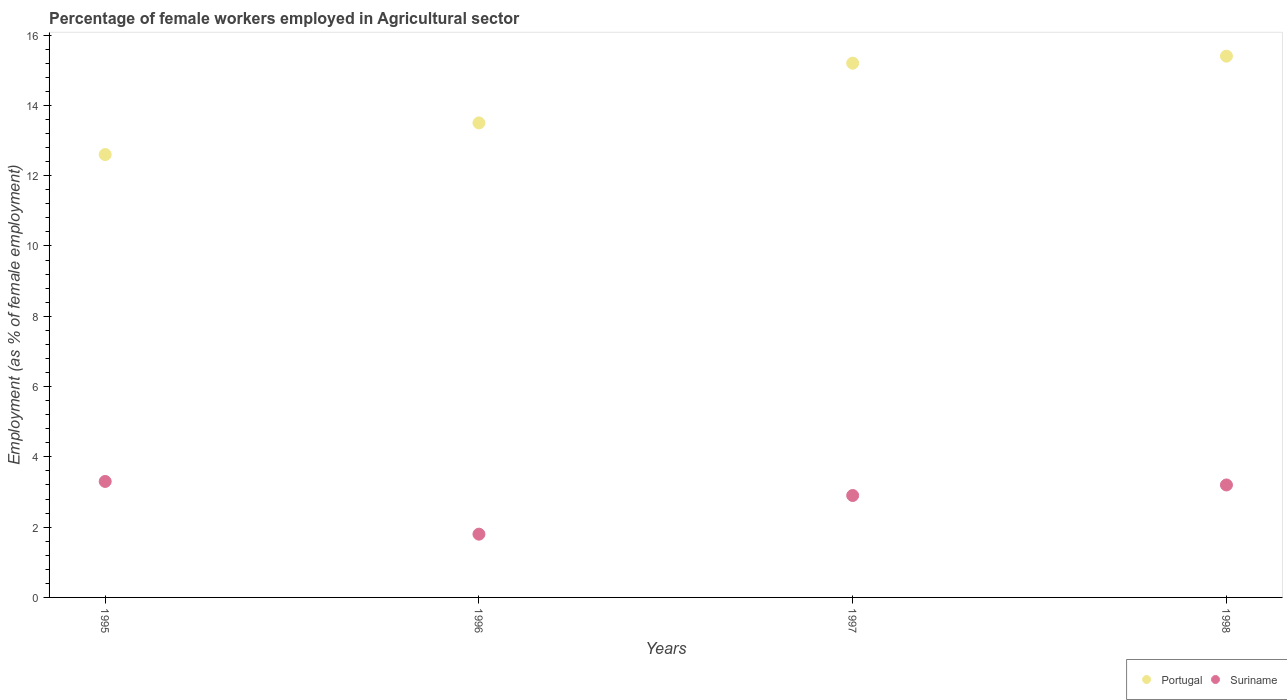Is the number of dotlines equal to the number of legend labels?
Offer a very short reply. Yes. What is the percentage of females employed in Agricultural sector in Suriname in 1996?
Ensure brevity in your answer.  1.8. Across all years, what is the maximum percentage of females employed in Agricultural sector in Portugal?
Offer a terse response. 15.4. Across all years, what is the minimum percentage of females employed in Agricultural sector in Portugal?
Ensure brevity in your answer.  12.6. In which year was the percentage of females employed in Agricultural sector in Portugal minimum?
Your response must be concise. 1995. What is the total percentage of females employed in Agricultural sector in Portugal in the graph?
Your response must be concise. 56.7. What is the difference between the percentage of females employed in Agricultural sector in Portugal in 1995 and that in 1998?
Make the answer very short. -2.8. What is the difference between the percentage of females employed in Agricultural sector in Suriname in 1997 and the percentage of females employed in Agricultural sector in Portugal in 1996?
Your answer should be compact. -10.6. What is the average percentage of females employed in Agricultural sector in Suriname per year?
Your answer should be compact. 2.8. In the year 1996, what is the difference between the percentage of females employed in Agricultural sector in Portugal and percentage of females employed in Agricultural sector in Suriname?
Offer a terse response. 11.7. In how many years, is the percentage of females employed in Agricultural sector in Portugal greater than 11.6 %?
Keep it short and to the point. 4. What is the ratio of the percentage of females employed in Agricultural sector in Portugal in 1995 to that in 1998?
Offer a very short reply. 0.82. Is the difference between the percentage of females employed in Agricultural sector in Portugal in 1995 and 1996 greater than the difference between the percentage of females employed in Agricultural sector in Suriname in 1995 and 1996?
Your answer should be compact. No. What is the difference between the highest and the second highest percentage of females employed in Agricultural sector in Portugal?
Offer a very short reply. 0.2. What is the difference between the highest and the lowest percentage of females employed in Agricultural sector in Suriname?
Ensure brevity in your answer.  1.5. In how many years, is the percentage of females employed in Agricultural sector in Suriname greater than the average percentage of females employed in Agricultural sector in Suriname taken over all years?
Your answer should be compact. 3. Is the sum of the percentage of females employed in Agricultural sector in Suriname in 1995 and 1996 greater than the maximum percentage of females employed in Agricultural sector in Portugal across all years?
Offer a very short reply. No. Is the percentage of females employed in Agricultural sector in Portugal strictly less than the percentage of females employed in Agricultural sector in Suriname over the years?
Ensure brevity in your answer.  No. How many dotlines are there?
Ensure brevity in your answer.  2. What is the difference between two consecutive major ticks on the Y-axis?
Offer a very short reply. 2. Does the graph contain any zero values?
Your answer should be very brief. No. Does the graph contain grids?
Your answer should be very brief. No. How many legend labels are there?
Provide a succinct answer. 2. How are the legend labels stacked?
Keep it short and to the point. Horizontal. What is the title of the graph?
Keep it short and to the point. Percentage of female workers employed in Agricultural sector. What is the label or title of the Y-axis?
Provide a succinct answer. Employment (as % of female employment). What is the Employment (as % of female employment) of Portugal in 1995?
Ensure brevity in your answer.  12.6. What is the Employment (as % of female employment) of Suriname in 1995?
Your answer should be compact. 3.3. What is the Employment (as % of female employment) of Suriname in 1996?
Make the answer very short. 1.8. What is the Employment (as % of female employment) in Portugal in 1997?
Give a very brief answer. 15.2. What is the Employment (as % of female employment) of Suriname in 1997?
Provide a succinct answer. 2.9. What is the Employment (as % of female employment) of Portugal in 1998?
Your answer should be very brief. 15.4. What is the Employment (as % of female employment) in Suriname in 1998?
Give a very brief answer. 3.2. Across all years, what is the maximum Employment (as % of female employment) in Portugal?
Your response must be concise. 15.4. Across all years, what is the maximum Employment (as % of female employment) in Suriname?
Keep it short and to the point. 3.3. Across all years, what is the minimum Employment (as % of female employment) in Portugal?
Give a very brief answer. 12.6. Across all years, what is the minimum Employment (as % of female employment) of Suriname?
Provide a short and direct response. 1.8. What is the total Employment (as % of female employment) in Portugal in the graph?
Your response must be concise. 56.7. What is the total Employment (as % of female employment) of Suriname in the graph?
Your answer should be compact. 11.2. What is the difference between the Employment (as % of female employment) of Suriname in 1995 and that in 1996?
Your answer should be very brief. 1.5. What is the difference between the Employment (as % of female employment) of Portugal in 1995 and that in 1998?
Keep it short and to the point. -2.8. What is the difference between the Employment (as % of female employment) of Suriname in 1995 and that in 1998?
Provide a succinct answer. 0.1. What is the difference between the Employment (as % of female employment) of Portugal in 1996 and that in 1998?
Keep it short and to the point. -1.9. What is the difference between the Employment (as % of female employment) of Suriname in 1996 and that in 1998?
Provide a short and direct response. -1.4. What is the difference between the Employment (as % of female employment) of Portugal in 1997 and that in 1998?
Make the answer very short. -0.2. What is the difference between the Employment (as % of female employment) of Portugal in 1995 and the Employment (as % of female employment) of Suriname in 1996?
Ensure brevity in your answer.  10.8. What is the difference between the Employment (as % of female employment) in Portugal in 1995 and the Employment (as % of female employment) in Suriname in 1997?
Keep it short and to the point. 9.7. What is the difference between the Employment (as % of female employment) of Portugal in 1996 and the Employment (as % of female employment) of Suriname in 1997?
Your answer should be very brief. 10.6. What is the difference between the Employment (as % of female employment) of Portugal in 1996 and the Employment (as % of female employment) of Suriname in 1998?
Offer a very short reply. 10.3. What is the average Employment (as % of female employment) in Portugal per year?
Provide a succinct answer. 14.18. In the year 1996, what is the difference between the Employment (as % of female employment) in Portugal and Employment (as % of female employment) in Suriname?
Offer a terse response. 11.7. In the year 1997, what is the difference between the Employment (as % of female employment) of Portugal and Employment (as % of female employment) of Suriname?
Give a very brief answer. 12.3. In the year 1998, what is the difference between the Employment (as % of female employment) of Portugal and Employment (as % of female employment) of Suriname?
Give a very brief answer. 12.2. What is the ratio of the Employment (as % of female employment) of Suriname in 1995 to that in 1996?
Keep it short and to the point. 1.83. What is the ratio of the Employment (as % of female employment) in Portugal in 1995 to that in 1997?
Offer a terse response. 0.83. What is the ratio of the Employment (as % of female employment) of Suriname in 1995 to that in 1997?
Keep it short and to the point. 1.14. What is the ratio of the Employment (as % of female employment) in Portugal in 1995 to that in 1998?
Keep it short and to the point. 0.82. What is the ratio of the Employment (as % of female employment) in Suriname in 1995 to that in 1998?
Keep it short and to the point. 1.03. What is the ratio of the Employment (as % of female employment) in Portugal in 1996 to that in 1997?
Provide a succinct answer. 0.89. What is the ratio of the Employment (as % of female employment) of Suriname in 1996 to that in 1997?
Give a very brief answer. 0.62. What is the ratio of the Employment (as % of female employment) of Portugal in 1996 to that in 1998?
Your answer should be very brief. 0.88. What is the ratio of the Employment (as % of female employment) of Suriname in 1996 to that in 1998?
Provide a short and direct response. 0.56. What is the ratio of the Employment (as % of female employment) in Portugal in 1997 to that in 1998?
Offer a terse response. 0.99. What is the ratio of the Employment (as % of female employment) of Suriname in 1997 to that in 1998?
Your answer should be compact. 0.91. What is the difference between the highest and the second highest Employment (as % of female employment) of Portugal?
Your answer should be compact. 0.2. What is the difference between the highest and the second highest Employment (as % of female employment) of Suriname?
Offer a very short reply. 0.1. What is the difference between the highest and the lowest Employment (as % of female employment) of Portugal?
Your answer should be very brief. 2.8. 